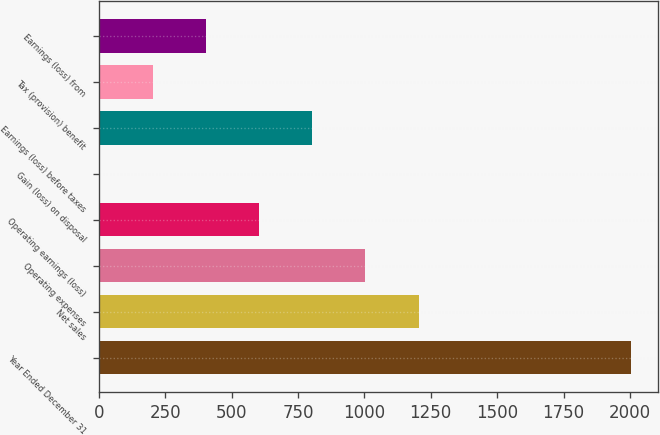<chart> <loc_0><loc_0><loc_500><loc_500><bar_chart><fcel>Year Ended December 31<fcel>Net sales<fcel>Operating expenses<fcel>Operating earnings (loss)<fcel>Gain (loss) on disposal<fcel>Earnings (loss) before taxes<fcel>Tax (provision) benefit<fcel>Earnings (loss) from<nl><fcel>2004<fcel>1204<fcel>1004<fcel>604<fcel>4<fcel>804<fcel>204<fcel>404<nl></chart> 